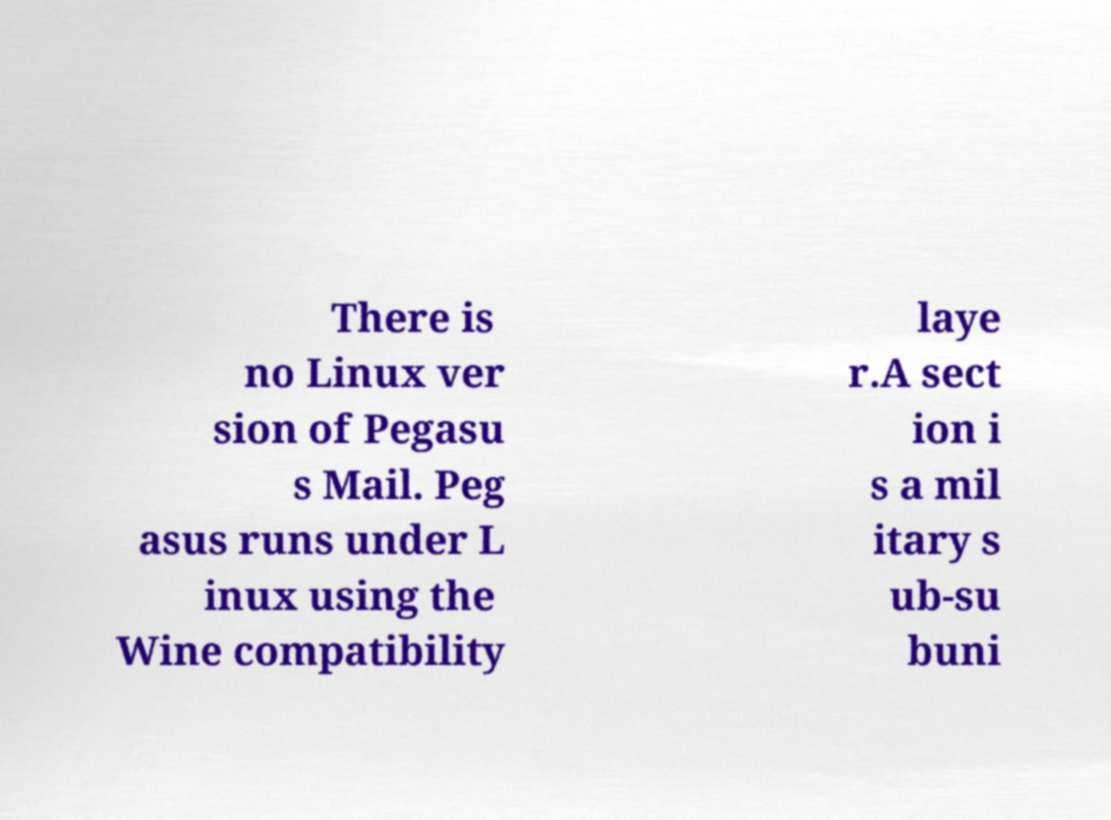For documentation purposes, I need the text within this image transcribed. Could you provide that? There is no Linux ver sion of Pegasu s Mail. Peg asus runs under L inux using the Wine compatibility laye r.A sect ion i s a mil itary s ub-su buni 